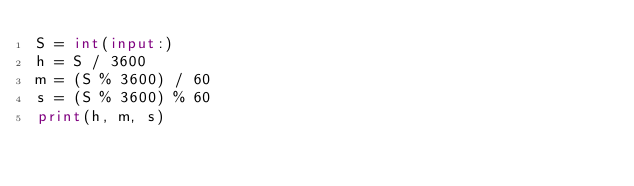<code> <loc_0><loc_0><loc_500><loc_500><_Python_>S = int(input:)
h = S / 3600
m = (S % 3600) / 60
s = (S % 3600) % 60
print(h, m, s)</code> 